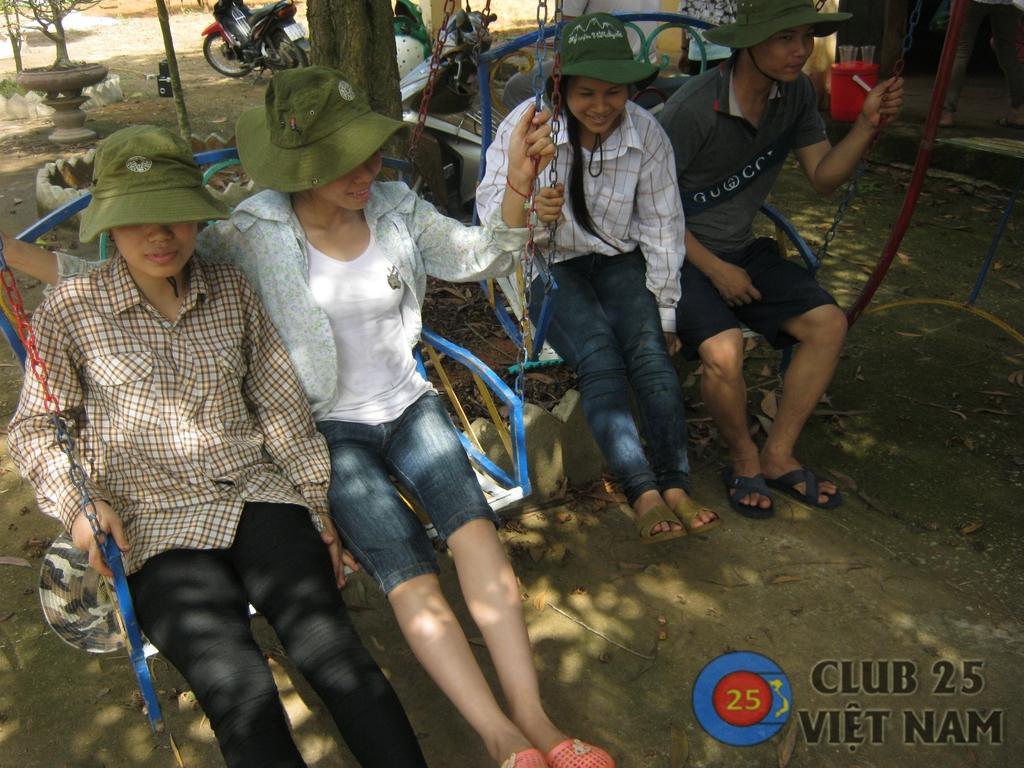Could you give a brief overview of what you see in this image? In this image we can see people sitting on swings. In the background of the image there are vehicles. To the right side of the image there is a red color bucket on which there are glasses. At the bottom of the image there is ground. There is some text. 